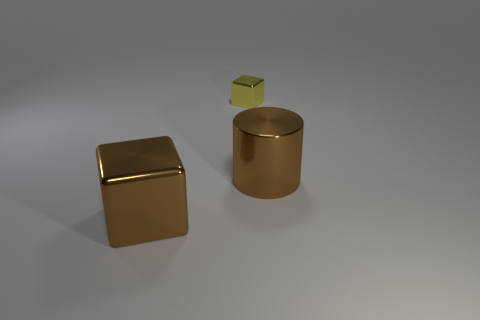Is there anything else that is the same size as the yellow shiny block?
Make the answer very short. No. Are there any small metal things to the right of the block on the right side of the large shiny thing that is to the left of the yellow metallic cube?
Your answer should be very brief. No. What number of other things are there of the same material as the big brown block
Ensure brevity in your answer.  2. What number of yellow cubes are there?
Give a very brief answer. 1. What number of things are metallic things or brown things to the right of the big brown metal block?
Your answer should be very brief. 3. Is there any other thing that has the same shape as the tiny metal thing?
Make the answer very short. Yes. There is a thing that is left of the yellow metallic thing; is it the same size as the tiny thing?
Give a very brief answer. No. How many matte things are small yellow objects or blocks?
Offer a terse response. 0. There is a brown metallic thing in front of the big metallic cylinder; what is its size?
Offer a terse response. Large. What number of large objects are yellow metallic cylinders or brown metal things?
Ensure brevity in your answer.  2. 